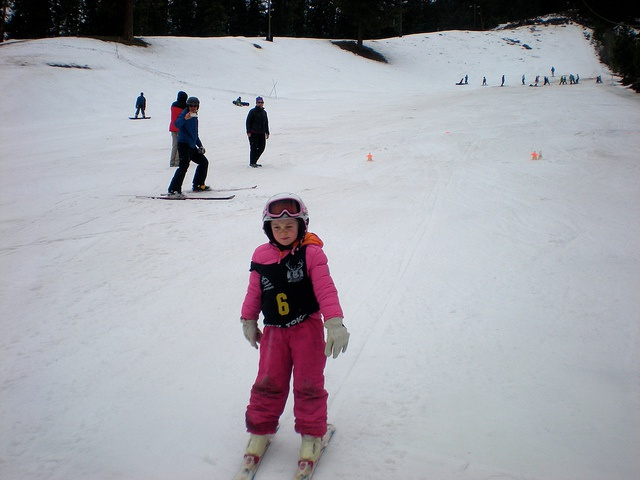Describe the objects in this image and their specific colors. I can see people in black, maroon, purple, and gray tones, people in black, navy, gray, and maroon tones, people in black, navy, gray, and lightgray tones, people in black, gray, brown, and maroon tones, and skis in black, darkgray, and gray tones in this image. 